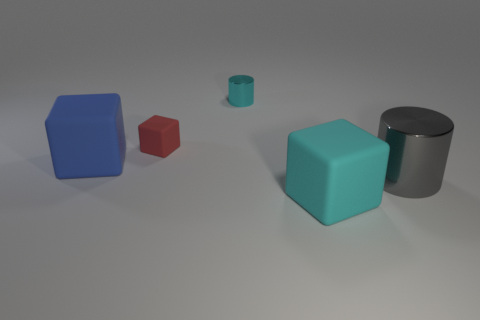Are there the same number of blue cubes behind the tiny metal cylinder and tiny blocks?
Your answer should be very brief. No. Is there a large matte block of the same color as the small cylinder?
Keep it short and to the point. Yes. Is the size of the gray shiny cylinder the same as the blue block?
Provide a succinct answer. Yes. What size is the metal object that is right of the big matte block that is to the right of the large blue thing?
Provide a succinct answer. Large. There is a matte thing that is on the right side of the blue matte object and behind the cyan rubber object; how big is it?
Offer a very short reply. Small. What number of blue blocks have the same size as the cyan cylinder?
Ensure brevity in your answer.  0. What number of rubber objects are either large gray objects or big things?
Your response must be concise. 2. The cube that is the same color as the small cylinder is what size?
Give a very brief answer. Large. What material is the cylinder that is to the right of the shiny cylinder behind the large gray cylinder made of?
Your answer should be very brief. Metal. What number of objects are large metal objects or metallic cylinders that are behind the large gray metal object?
Ensure brevity in your answer.  2. 